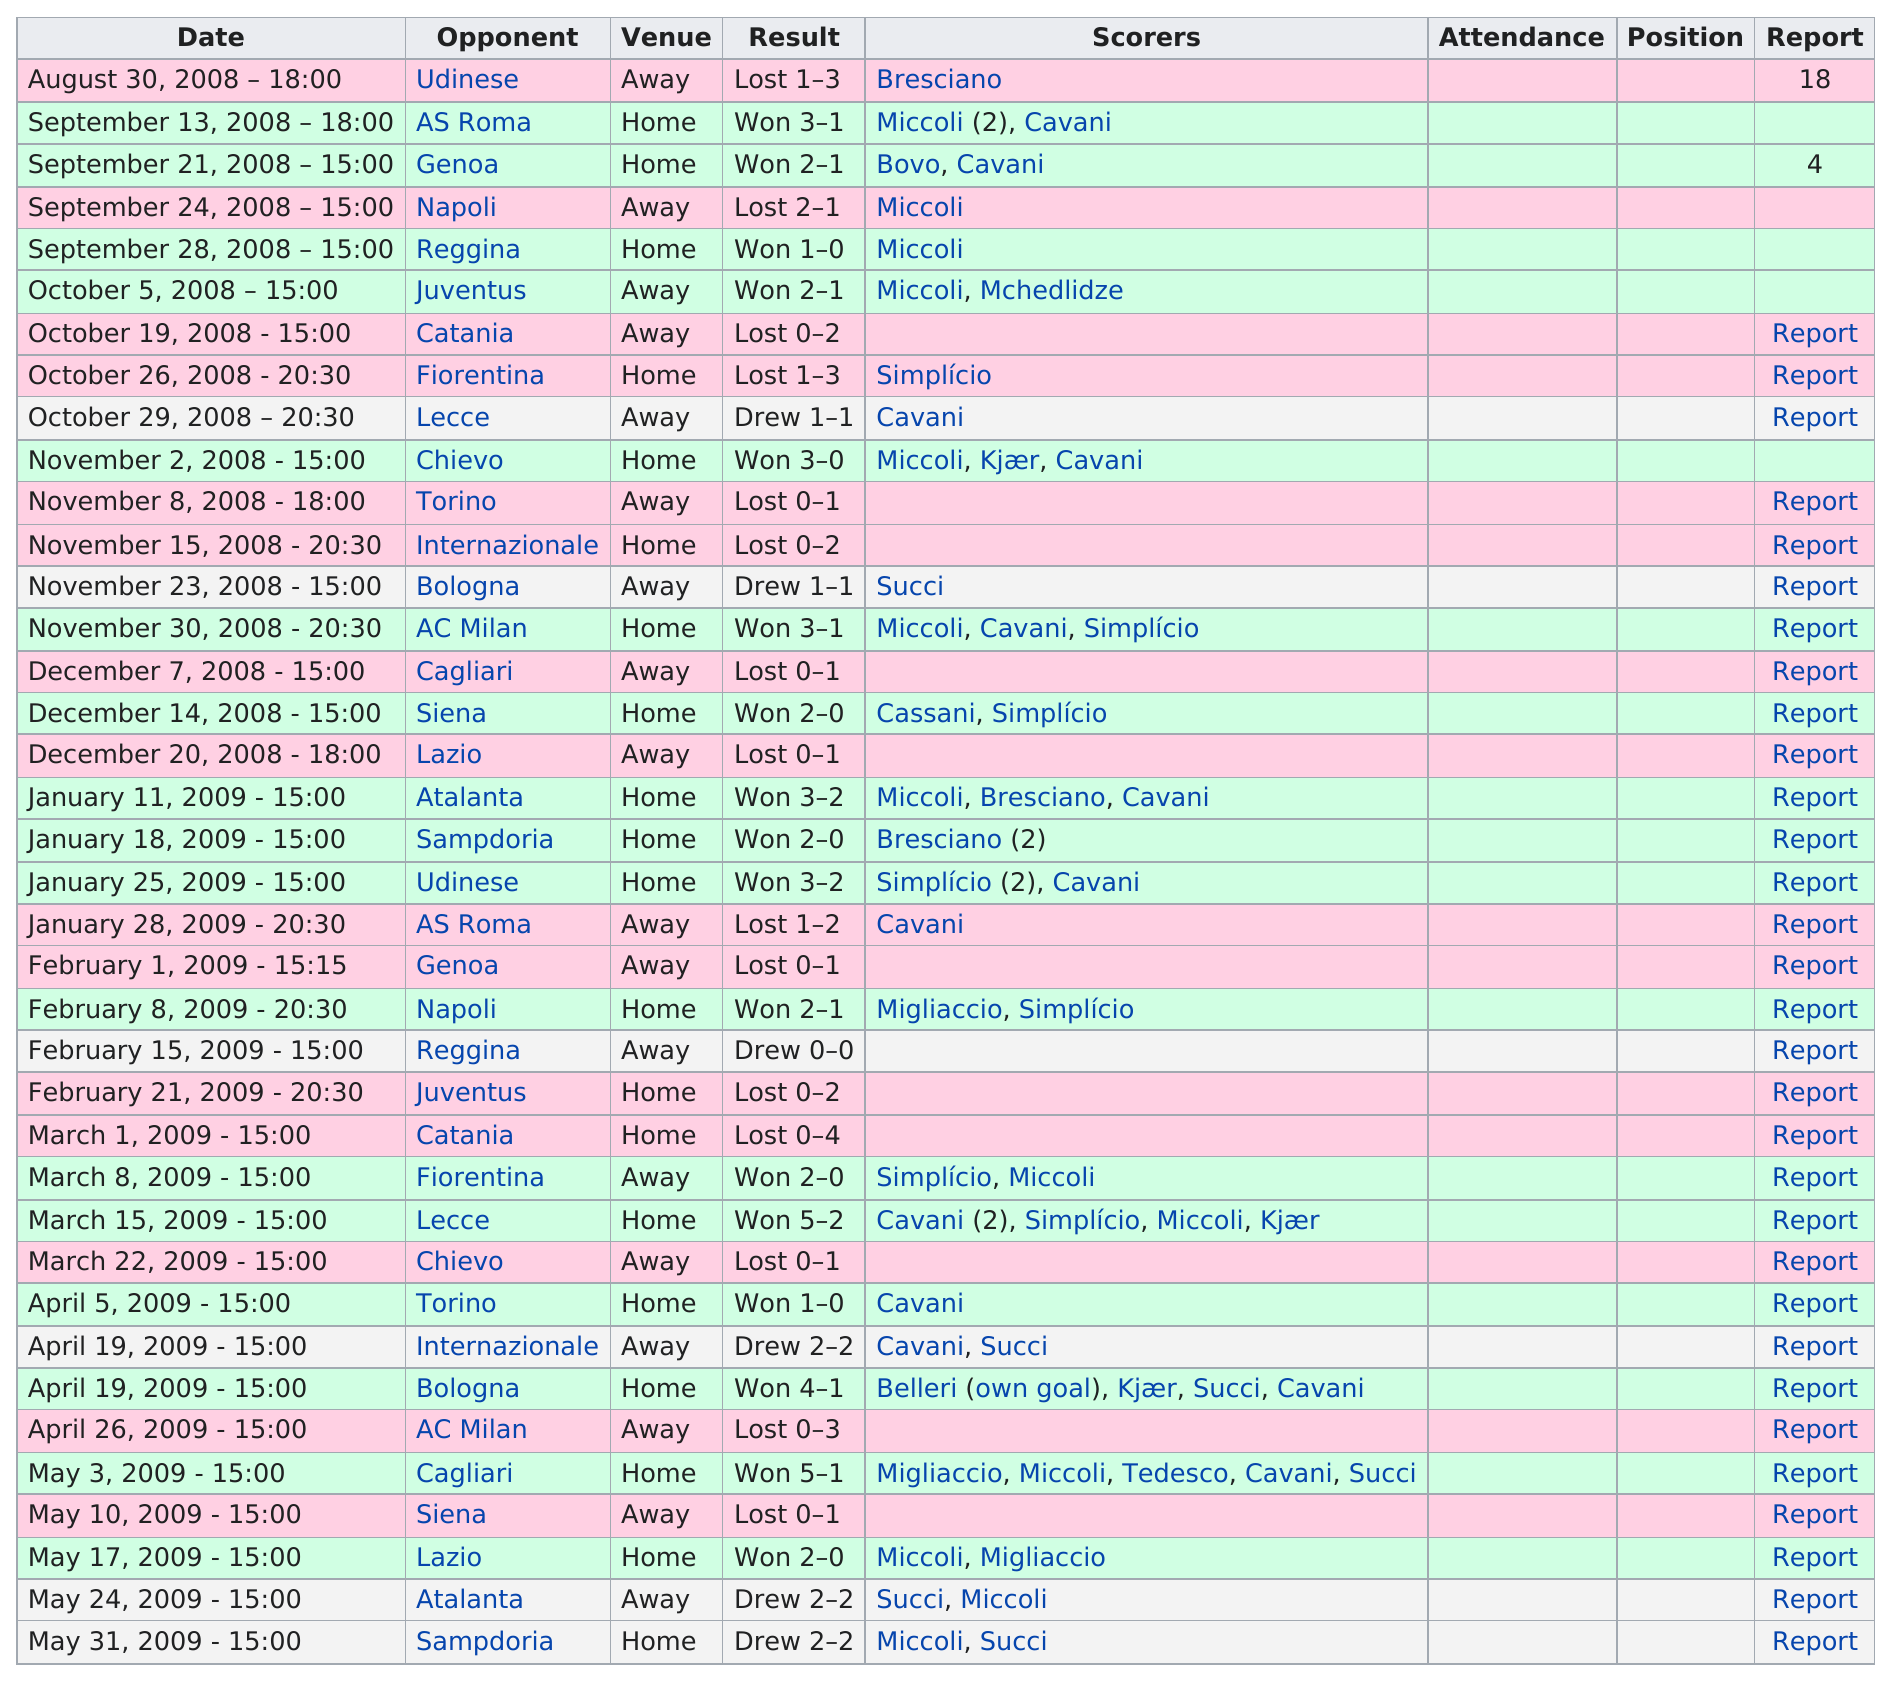Identify some key points in this picture. The longest consecutive win streak was three games. On October 19, 2008, the goal difference was 2. Out of the total number of matches played, 15 matches were lost. The total number of different teams listed as an opponent is 19. On October 5, 2008, a total of three matches were won. 